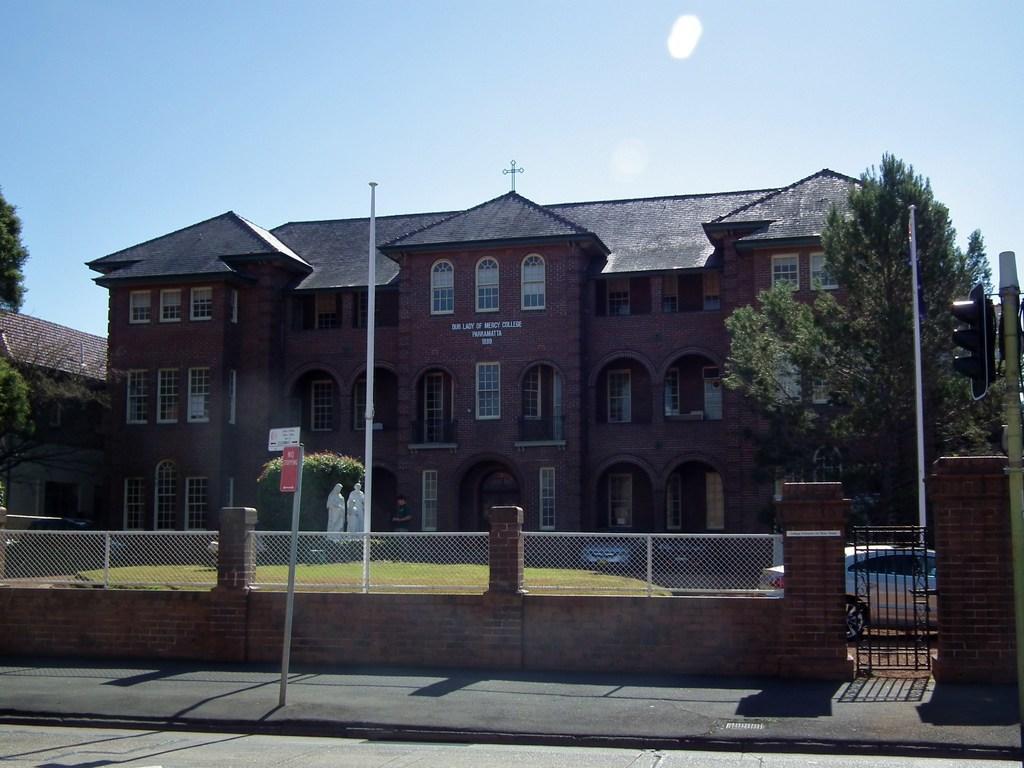How would you summarize this image in a sentence or two? This picture shows couple of buildings and we see trees and couple of poles and a fence with a gate and we see a car parked and a sign board on the sidewalk and we see a cloudy sky. 